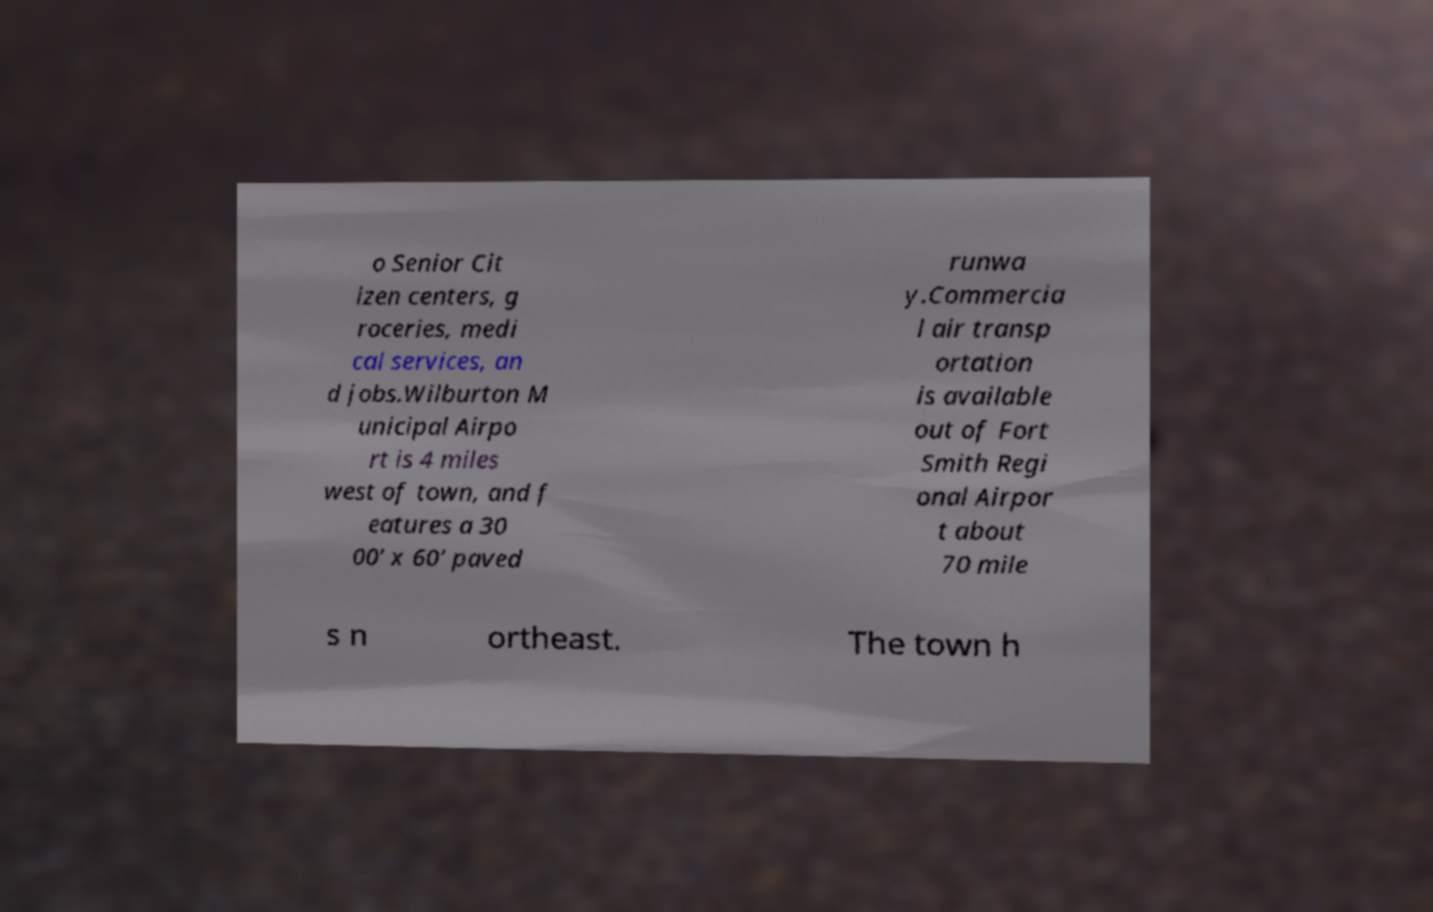Could you extract and type out the text from this image? o Senior Cit izen centers, g roceries, medi cal services, an d jobs.Wilburton M unicipal Airpo rt is 4 miles west of town, and f eatures a 30 00’ x 60’ paved runwa y.Commercia l air transp ortation is available out of Fort Smith Regi onal Airpor t about 70 mile s n ortheast. The town h 